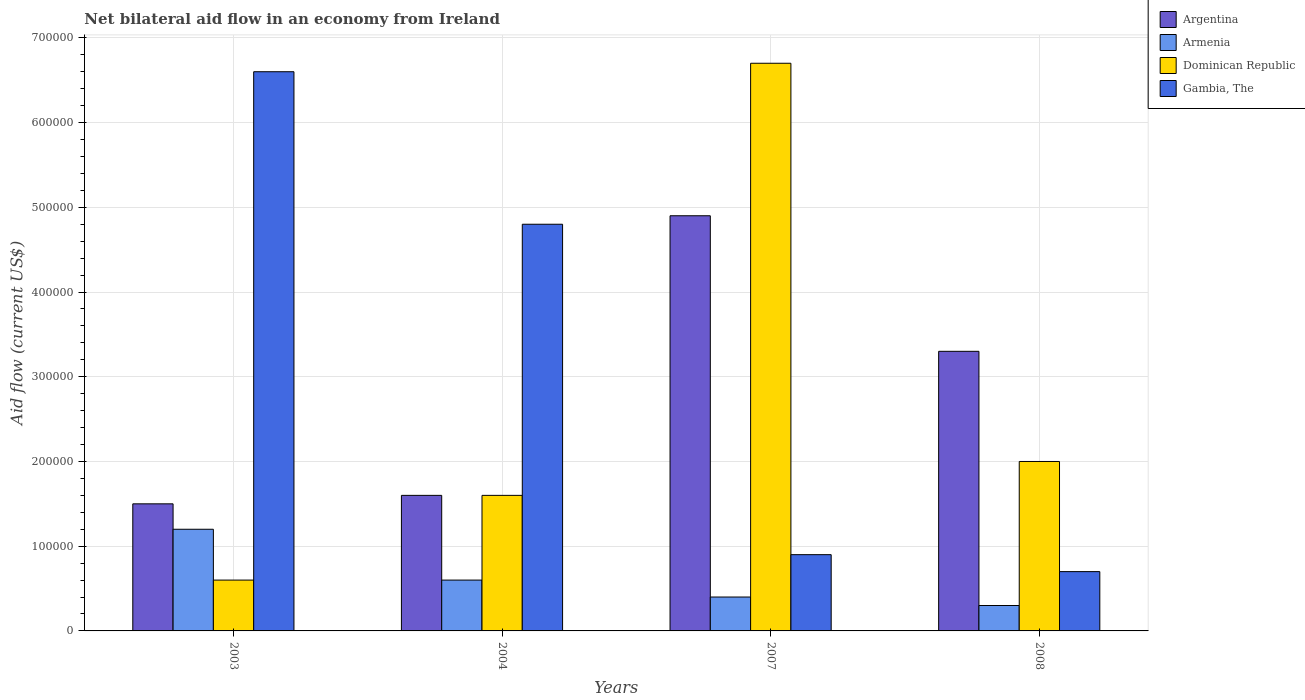How many bars are there on the 3rd tick from the right?
Ensure brevity in your answer.  4. What is the label of the 1st group of bars from the left?
Ensure brevity in your answer.  2003. In how many cases, is the number of bars for a given year not equal to the number of legend labels?
Provide a short and direct response. 0. What is the net bilateral aid flow in Gambia, The in 2003?
Provide a short and direct response. 6.60e+05. Across all years, what is the maximum net bilateral aid flow in Armenia?
Provide a succinct answer. 1.20e+05. What is the total net bilateral aid flow in Gambia, The in the graph?
Your response must be concise. 1.30e+06. What is the difference between the net bilateral aid flow in Argentina in 2003 and that in 2004?
Your response must be concise. -10000. What is the difference between the net bilateral aid flow in Dominican Republic in 2008 and the net bilateral aid flow in Armenia in 2003?
Make the answer very short. 8.00e+04. What is the average net bilateral aid flow in Armenia per year?
Give a very brief answer. 6.25e+04. In the year 2003, what is the difference between the net bilateral aid flow in Armenia and net bilateral aid flow in Dominican Republic?
Offer a very short reply. 6.00e+04. In how many years, is the net bilateral aid flow in Dominican Republic greater than 40000 US$?
Keep it short and to the point. 4. What is the ratio of the net bilateral aid flow in Armenia in 2007 to that in 2008?
Your response must be concise. 1.33. Is the net bilateral aid flow in Dominican Republic in 2004 less than that in 2007?
Give a very brief answer. Yes. What is the difference between the highest and the second highest net bilateral aid flow in Argentina?
Offer a very short reply. 1.60e+05. Is it the case that in every year, the sum of the net bilateral aid flow in Dominican Republic and net bilateral aid flow in Argentina is greater than the sum of net bilateral aid flow in Armenia and net bilateral aid flow in Gambia, The?
Your answer should be compact. No. What does the 4th bar from the left in 2003 represents?
Your response must be concise. Gambia, The. What does the 1st bar from the right in 2004 represents?
Provide a short and direct response. Gambia, The. Is it the case that in every year, the sum of the net bilateral aid flow in Gambia, The and net bilateral aid flow in Dominican Republic is greater than the net bilateral aid flow in Argentina?
Provide a short and direct response. No. What is the difference between two consecutive major ticks on the Y-axis?
Your response must be concise. 1.00e+05. How many legend labels are there?
Your answer should be very brief. 4. How are the legend labels stacked?
Keep it short and to the point. Vertical. What is the title of the graph?
Provide a short and direct response. Net bilateral aid flow in an economy from Ireland. What is the label or title of the Y-axis?
Keep it short and to the point. Aid flow (current US$). What is the Aid flow (current US$) in Argentina in 2003?
Give a very brief answer. 1.50e+05. What is the Aid flow (current US$) of Armenia in 2003?
Your answer should be very brief. 1.20e+05. What is the Aid flow (current US$) in Dominican Republic in 2003?
Provide a short and direct response. 6.00e+04. What is the Aid flow (current US$) in Argentina in 2004?
Keep it short and to the point. 1.60e+05. What is the Aid flow (current US$) in Armenia in 2004?
Keep it short and to the point. 6.00e+04. What is the Aid flow (current US$) in Dominican Republic in 2004?
Provide a succinct answer. 1.60e+05. What is the Aid flow (current US$) of Armenia in 2007?
Keep it short and to the point. 4.00e+04. What is the Aid flow (current US$) in Dominican Republic in 2007?
Make the answer very short. 6.70e+05. What is the Aid flow (current US$) of Argentina in 2008?
Make the answer very short. 3.30e+05. What is the Aid flow (current US$) in Dominican Republic in 2008?
Give a very brief answer. 2.00e+05. What is the Aid flow (current US$) of Gambia, The in 2008?
Offer a terse response. 7.00e+04. Across all years, what is the maximum Aid flow (current US$) in Armenia?
Your answer should be very brief. 1.20e+05. Across all years, what is the maximum Aid flow (current US$) of Dominican Republic?
Your answer should be very brief. 6.70e+05. Across all years, what is the minimum Aid flow (current US$) in Armenia?
Make the answer very short. 3.00e+04. Across all years, what is the minimum Aid flow (current US$) of Dominican Republic?
Make the answer very short. 6.00e+04. Across all years, what is the minimum Aid flow (current US$) of Gambia, The?
Your answer should be very brief. 7.00e+04. What is the total Aid flow (current US$) in Argentina in the graph?
Offer a terse response. 1.13e+06. What is the total Aid flow (current US$) in Armenia in the graph?
Provide a succinct answer. 2.50e+05. What is the total Aid flow (current US$) in Dominican Republic in the graph?
Offer a very short reply. 1.09e+06. What is the total Aid flow (current US$) of Gambia, The in the graph?
Offer a very short reply. 1.30e+06. What is the difference between the Aid flow (current US$) of Argentina in 2003 and that in 2004?
Keep it short and to the point. -10000. What is the difference between the Aid flow (current US$) in Armenia in 2003 and that in 2004?
Ensure brevity in your answer.  6.00e+04. What is the difference between the Aid flow (current US$) of Dominican Republic in 2003 and that in 2004?
Give a very brief answer. -1.00e+05. What is the difference between the Aid flow (current US$) of Gambia, The in 2003 and that in 2004?
Make the answer very short. 1.80e+05. What is the difference between the Aid flow (current US$) of Argentina in 2003 and that in 2007?
Ensure brevity in your answer.  -3.40e+05. What is the difference between the Aid flow (current US$) of Dominican Republic in 2003 and that in 2007?
Make the answer very short. -6.10e+05. What is the difference between the Aid flow (current US$) in Gambia, The in 2003 and that in 2007?
Provide a succinct answer. 5.70e+05. What is the difference between the Aid flow (current US$) of Argentina in 2003 and that in 2008?
Make the answer very short. -1.80e+05. What is the difference between the Aid flow (current US$) in Dominican Republic in 2003 and that in 2008?
Keep it short and to the point. -1.40e+05. What is the difference between the Aid flow (current US$) of Gambia, The in 2003 and that in 2008?
Offer a very short reply. 5.90e+05. What is the difference between the Aid flow (current US$) of Argentina in 2004 and that in 2007?
Provide a succinct answer. -3.30e+05. What is the difference between the Aid flow (current US$) of Dominican Republic in 2004 and that in 2007?
Make the answer very short. -5.10e+05. What is the difference between the Aid flow (current US$) in Argentina in 2004 and that in 2008?
Your response must be concise. -1.70e+05. What is the difference between the Aid flow (current US$) of Gambia, The in 2004 and that in 2008?
Keep it short and to the point. 4.10e+05. What is the difference between the Aid flow (current US$) of Armenia in 2007 and that in 2008?
Your answer should be compact. 10000. What is the difference between the Aid flow (current US$) of Dominican Republic in 2007 and that in 2008?
Offer a very short reply. 4.70e+05. What is the difference between the Aid flow (current US$) in Argentina in 2003 and the Aid flow (current US$) in Gambia, The in 2004?
Offer a very short reply. -3.30e+05. What is the difference between the Aid flow (current US$) in Armenia in 2003 and the Aid flow (current US$) in Dominican Republic in 2004?
Keep it short and to the point. -4.00e+04. What is the difference between the Aid flow (current US$) of Armenia in 2003 and the Aid flow (current US$) of Gambia, The in 2004?
Give a very brief answer. -3.60e+05. What is the difference between the Aid flow (current US$) in Dominican Republic in 2003 and the Aid flow (current US$) in Gambia, The in 2004?
Your answer should be compact. -4.20e+05. What is the difference between the Aid flow (current US$) in Argentina in 2003 and the Aid flow (current US$) in Armenia in 2007?
Keep it short and to the point. 1.10e+05. What is the difference between the Aid flow (current US$) of Argentina in 2003 and the Aid flow (current US$) of Dominican Republic in 2007?
Your answer should be very brief. -5.20e+05. What is the difference between the Aid flow (current US$) in Argentina in 2003 and the Aid flow (current US$) in Gambia, The in 2007?
Provide a succinct answer. 6.00e+04. What is the difference between the Aid flow (current US$) in Armenia in 2003 and the Aid flow (current US$) in Dominican Republic in 2007?
Keep it short and to the point. -5.50e+05. What is the difference between the Aid flow (current US$) of Armenia in 2003 and the Aid flow (current US$) of Gambia, The in 2007?
Make the answer very short. 3.00e+04. What is the difference between the Aid flow (current US$) in Argentina in 2003 and the Aid flow (current US$) in Armenia in 2008?
Your answer should be compact. 1.20e+05. What is the difference between the Aid flow (current US$) in Argentina in 2003 and the Aid flow (current US$) in Dominican Republic in 2008?
Your answer should be compact. -5.00e+04. What is the difference between the Aid flow (current US$) in Armenia in 2003 and the Aid flow (current US$) in Gambia, The in 2008?
Provide a succinct answer. 5.00e+04. What is the difference between the Aid flow (current US$) in Argentina in 2004 and the Aid flow (current US$) in Dominican Republic in 2007?
Keep it short and to the point. -5.10e+05. What is the difference between the Aid flow (current US$) in Armenia in 2004 and the Aid flow (current US$) in Dominican Republic in 2007?
Offer a terse response. -6.10e+05. What is the difference between the Aid flow (current US$) of Argentina in 2004 and the Aid flow (current US$) of Armenia in 2008?
Make the answer very short. 1.30e+05. What is the difference between the Aid flow (current US$) of Argentina in 2004 and the Aid flow (current US$) of Gambia, The in 2008?
Offer a very short reply. 9.00e+04. What is the difference between the Aid flow (current US$) in Armenia in 2004 and the Aid flow (current US$) in Dominican Republic in 2008?
Keep it short and to the point. -1.40e+05. What is the difference between the Aid flow (current US$) of Armenia in 2004 and the Aid flow (current US$) of Gambia, The in 2008?
Your response must be concise. -10000. What is the difference between the Aid flow (current US$) in Dominican Republic in 2004 and the Aid flow (current US$) in Gambia, The in 2008?
Your answer should be compact. 9.00e+04. What is the difference between the Aid flow (current US$) of Argentina in 2007 and the Aid flow (current US$) of Dominican Republic in 2008?
Keep it short and to the point. 2.90e+05. What is the average Aid flow (current US$) in Argentina per year?
Your response must be concise. 2.82e+05. What is the average Aid flow (current US$) of Armenia per year?
Provide a short and direct response. 6.25e+04. What is the average Aid flow (current US$) of Dominican Republic per year?
Keep it short and to the point. 2.72e+05. What is the average Aid flow (current US$) in Gambia, The per year?
Offer a very short reply. 3.25e+05. In the year 2003, what is the difference between the Aid flow (current US$) of Argentina and Aid flow (current US$) of Armenia?
Offer a terse response. 3.00e+04. In the year 2003, what is the difference between the Aid flow (current US$) of Argentina and Aid flow (current US$) of Gambia, The?
Keep it short and to the point. -5.10e+05. In the year 2003, what is the difference between the Aid flow (current US$) in Armenia and Aid flow (current US$) in Dominican Republic?
Offer a terse response. 6.00e+04. In the year 2003, what is the difference between the Aid flow (current US$) in Armenia and Aid flow (current US$) in Gambia, The?
Your response must be concise. -5.40e+05. In the year 2003, what is the difference between the Aid flow (current US$) of Dominican Republic and Aid flow (current US$) of Gambia, The?
Give a very brief answer. -6.00e+05. In the year 2004, what is the difference between the Aid flow (current US$) in Argentina and Aid flow (current US$) in Dominican Republic?
Keep it short and to the point. 0. In the year 2004, what is the difference between the Aid flow (current US$) in Argentina and Aid flow (current US$) in Gambia, The?
Keep it short and to the point. -3.20e+05. In the year 2004, what is the difference between the Aid flow (current US$) in Armenia and Aid flow (current US$) in Gambia, The?
Make the answer very short. -4.20e+05. In the year 2004, what is the difference between the Aid flow (current US$) of Dominican Republic and Aid flow (current US$) of Gambia, The?
Your response must be concise. -3.20e+05. In the year 2007, what is the difference between the Aid flow (current US$) of Argentina and Aid flow (current US$) of Dominican Republic?
Provide a short and direct response. -1.80e+05. In the year 2007, what is the difference between the Aid flow (current US$) in Armenia and Aid flow (current US$) in Dominican Republic?
Give a very brief answer. -6.30e+05. In the year 2007, what is the difference between the Aid flow (current US$) of Dominican Republic and Aid flow (current US$) of Gambia, The?
Your response must be concise. 5.80e+05. In the year 2008, what is the difference between the Aid flow (current US$) of Argentina and Aid flow (current US$) of Armenia?
Make the answer very short. 3.00e+05. In the year 2008, what is the difference between the Aid flow (current US$) of Argentina and Aid flow (current US$) of Gambia, The?
Your answer should be compact. 2.60e+05. In the year 2008, what is the difference between the Aid flow (current US$) of Dominican Republic and Aid flow (current US$) of Gambia, The?
Your answer should be very brief. 1.30e+05. What is the ratio of the Aid flow (current US$) in Gambia, The in 2003 to that in 2004?
Provide a succinct answer. 1.38. What is the ratio of the Aid flow (current US$) in Argentina in 2003 to that in 2007?
Offer a terse response. 0.31. What is the ratio of the Aid flow (current US$) in Dominican Republic in 2003 to that in 2007?
Your response must be concise. 0.09. What is the ratio of the Aid flow (current US$) in Gambia, The in 2003 to that in 2007?
Your response must be concise. 7.33. What is the ratio of the Aid flow (current US$) in Argentina in 2003 to that in 2008?
Give a very brief answer. 0.45. What is the ratio of the Aid flow (current US$) in Dominican Republic in 2003 to that in 2008?
Provide a succinct answer. 0.3. What is the ratio of the Aid flow (current US$) in Gambia, The in 2003 to that in 2008?
Ensure brevity in your answer.  9.43. What is the ratio of the Aid flow (current US$) of Argentina in 2004 to that in 2007?
Provide a short and direct response. 0.33. What is the ratio of the Aid flow (current US$) of Armenia in 2004 to that in 2007?
Your response must be concise. 1.5. What is the ratio of the Aid flow (current US$) of Dominican Republic in 2004 to that in 2007?
Provide a short and direct response. 0.24. What is the ratio of the Aid flow (current US$) in Gambia, The in 2004 to that in 2007?
Provide a succinct answer. 5.33. What is the ratio of the Aid flow (current US$) of Argentina in 2004 to that in 2008?
Ensure brevity in your answer.  0.48. What is the ratio of the Aid flow (current US$) of Armenia in 2004 to that in 2008?
Your answer should be compact. 2. What is the ratio of the Aid flow (current US$) in Gambia, The in 2004 to that in 2008?
Provide a short and direct response. 6.86. What is the ratio of the Aid flow (current US$) of Argentina in 2007 to that in 2008?
Provide a succinct answer. 1.48. What is the ratio of the Aid flow (current US$) of Armenia in 2007 to that in 2008?
Ensure brevity in your answer.  1.33. What is the ratio of the Aid flow (current US$) of Dominican Republic in 2007 to that in 2008?
Give a very brief answer. 3.35. What is the difference between the highest and the second highest Aid flow (current US$) of Armenia?
Offer a very short reply. 6.00e+04. What is the difference between the highest and the second highest Aid flow (current US$) of Dominican Republic?
Your answer should be very brief. 4.70e+05. What is the difference between the highest and the lowest Aid flow (current US$) in Argentina?
Offer a terse response. 3.40e+05. What is the difference between the highest and the lowest Aid flow (current US$) of Armenia?
Give a very brief answer. 9.00e+04. What is the difference between the highest and the lowest Aid flow (current US$) in Dominican Republic?
Your answer should be compact. 6.10e+05. What is the difference between the highest and the lowest Aid flow (current US$) in Gambia, The?
Ensure brevity in your answer.  5.90e+05. 